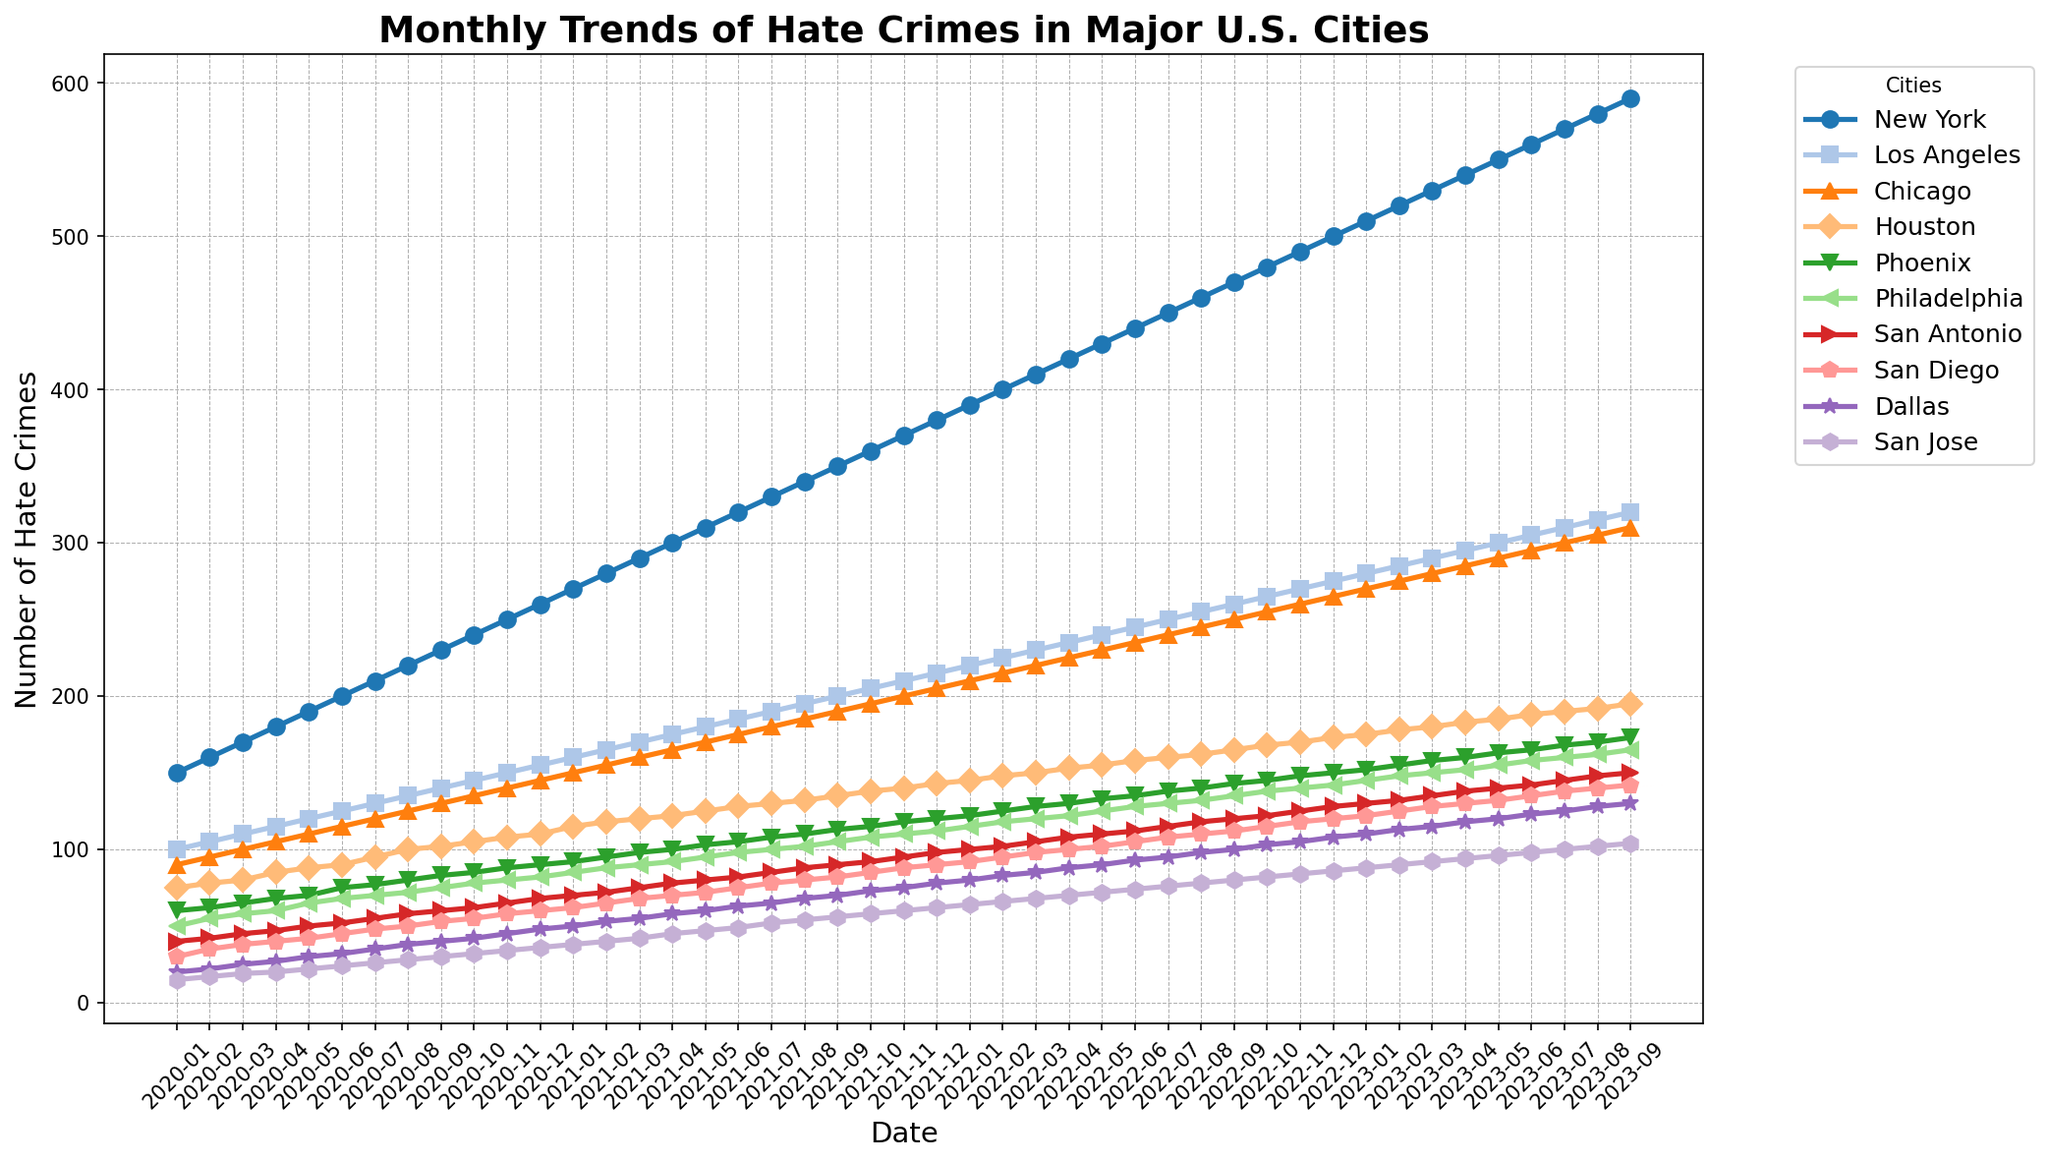Which city had the highest number of hate crimes in September 2023? Look at the plotted lines for each city in September 2023 and identify the line that reaches the highest point on the y-axis. The line for New York is at the top in September 2023.
Answer: New York Between Los Angeles and Chicago, which city saw a greater increase in hate crimes from January 2021 to December 2022? Calculate the difference in hate crimes for each city between January 2021 and December 2022, then compare the differences. Los Angeles: 275 - 160 = 115, Chicago: 265 - 150 = 115. Both cities have the same increase.
Answer: Equal increase During which month did Phoenix surpass Philadelphia in hate crimes for the first time? Track the point where the line representing Phoenix overtakes the line representing Philadelphia. This occurs around October 2021.
Answer: October 2021 What was the average number of hate crimes in San Jose from January 2022 to December 2022? Sum the monthly hate crime values for San Jose between January and December 2022 and divide by 12. (64 + 66 + 68 + 70 + 72 + 74 + 76 + 78 + 80 + 82 + 84 + 86) / 12 = 75
Answer: 75 How many cities had over 300 hate crimes by December 2023? Identify the cities with y-axis values surpassing 300 at the end of December 2023. These are New York, Los Angeles, and Chicago.
Answer: 3 Which city experienced the sharpest rise in hate crimes between June 2023 and July 2023? Compare the slopes of the lines for each city between June 2023 and July 2023. The rise is the steepest for New York, as indicated by the highest increase in y-axis value (570 - 560 = 10).
Answer: New York What is the total number of hate crimes reported in Houston from January 2020 through December 2021? Sum the monthly hate crime values in Houston from January 2020 to December 2021. Calculated as: 75+78+80+85+88+90+95+100+102+105+108+110+115+118+120+122+125+128+130+132+135+138+140+143 = 2401
Answer: 2401 What was the trend in hate crimes for San Diego from July 2022 to December 2022? Observe the plotted line for San Diego between July 2022 and December 2022 to determine if the number of hate crimes increased, decreased, or remained steady. The trend shows a consistent increase each month.
Answer: Increased 